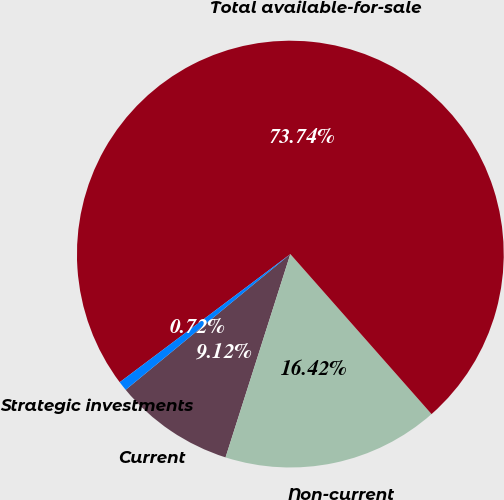Convert chart to OTSL. <chart><loc_0><loc_0><loc_500><loc_500><pie_chart><fcel>Current<fcel>Non-current<fcel>Total available-for-sale<fcel>Strategic investments<nl><fcel>9.12%<fcel>16.42%<fcel>73.75%<fcel>0.72%<nl></chart> 